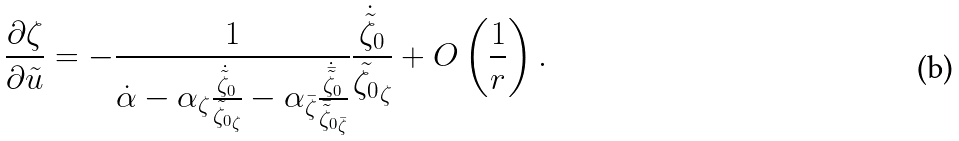Convert formula to latex. <formula><loc_0><loc_0><loc_500><loc_500>\frac { \partial \zeta } { \partial \tilde { u } } = - \frac { 1 } { \dot { \alpha } - \alpha _ { \zeta } \frac { \dot { \tilde { \zeta } } _ { 0 } } { \tilde { \zeta _ { 0 } } _ { \zeta } } - \alpha _ { \bar { \zeta } } \frac { \dot { \bar { \tilde { \zeta } } } _ { 0 } } { { \bar { \tilde { \zeta } } _ { 0 } } _ { \bar { \zeta } } } } \frac { \dot { \tilde { \zeta } } _ { 0 } } { \tilde { \zeta _ { 0 } } _ { \zeta } } + O \left ( \frac { 1 } { r } \right ) .</formula> 